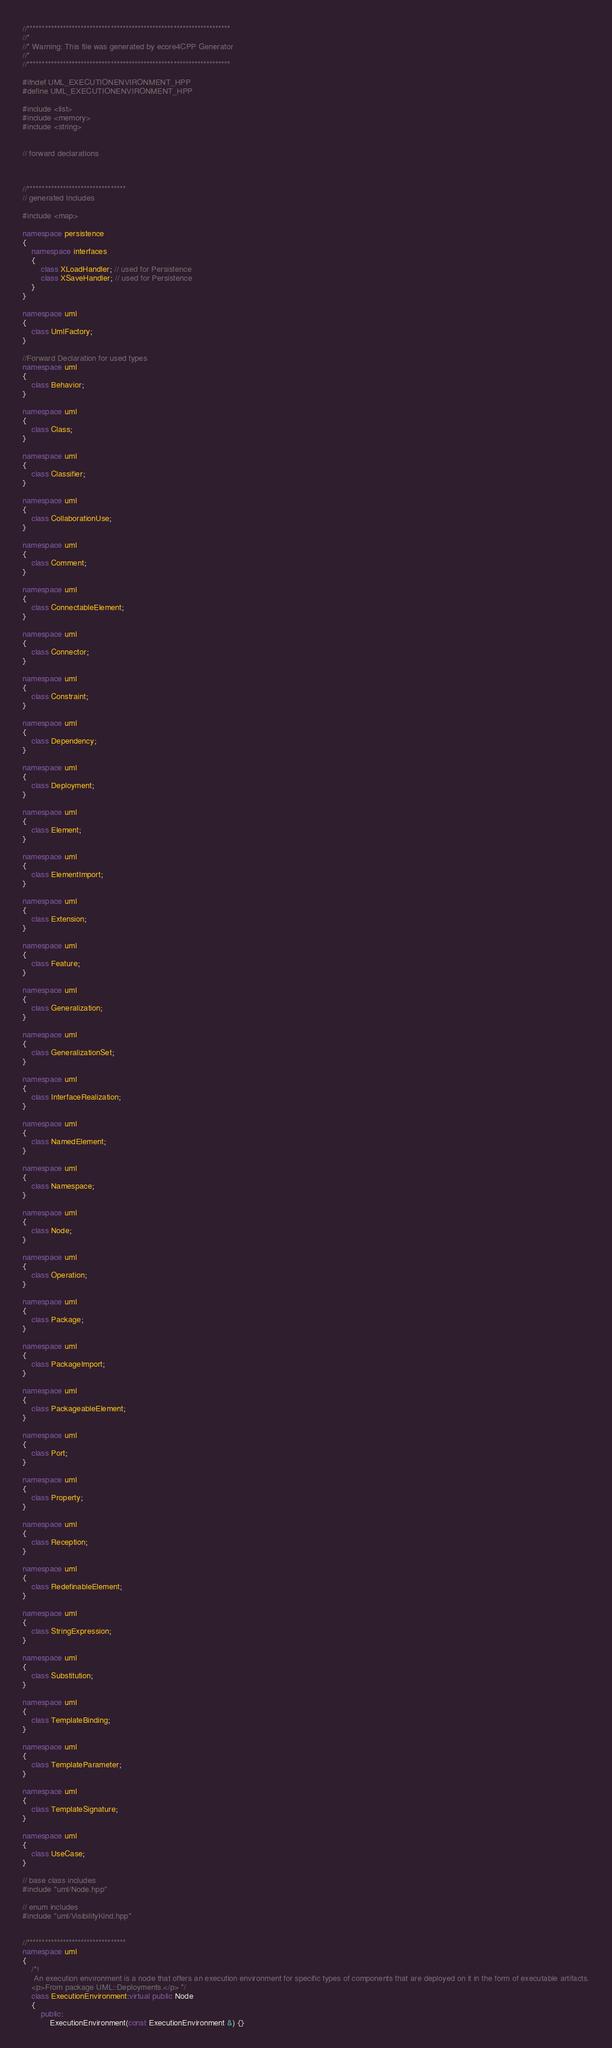Convert code to text. <code><loc_0><loc_0><loc_500><loc_500><_C++_>//********************************************************************
//*    
//* Warning: This file was generated by ecore4CPP Generator
//*
//********************************************************************

#ifndef UML_EXECUTIONENVIRONMENT_HPP
#define UML_EXECUTIONENVIRONMENT_HPP

#include <list>
#include <memory>
#include <string>


// forward declarations



//*********************************
// generated Includes

#include <map>

namespace persistence
{
	namespace interfaces
	{
		class XLoadHandler; // used for Persistence
		class XSaveHandler; // used for Persistence
	}
}

namespace uml
{
	class UmlFactory;
}

//Forward Declaration for used types
namespace uml 
{
	class Behavior;
}

namespace uml 
{
	class Class;
}

namespace uml 
{
	class Classifier;
}

namespace uml 
{
	class CollaborationUse;
}

namespace uml 
{
	class Comment;
}

namespace uml 
{
	class ConnectableElement;
}

namespace uml 
{
	class Connector;
}

namespace uml 
{
	class Constraint;
}

namespace uml 
{
	class Dependency;
}

namespace uml 
{
	class Deployment;
}

namespace uml 
{
	class Element;
}

namespace uml 
{
	class ElementImport;
}

namespace uml 
{
	class Extension;
}

namespace uml 
{
	class Feature;
}

namespace uml 
{
	class Generalization;
}

namespace uml 
{
	class GeneralizationSet;
}

namespace uml 
{
	class InterfaceRealization;
}

namespace uml 
{
	class NamedElement;
}

namespace uml 
{
	class Namespace;
}

namespace uml 
{
	class Node;
}

namespace uml 
{
	class Operation;
}

namespace uml 
{
	class Package;
}

namespace uml 
{
	class PackageImport;
}

namespace uml 
{
	class PackageableElement;
}

namespace uml 
{
	class Port;
}

namespace uml 
{
	class Property;
}

namespace uml 
{
	class Reception;
}

namespace uml 
{
	class RedefinableElement;
}

namespace uml 
{
	class StringExpression;
}

namespace uml 
{
	class Substitution;
}

namespace uml 
{
	class TemplateBinding;
}

namespace uml 
{
	class TemplateParameter;
}

namespace uml 
{
	class TemplateSignature;
}

namespace uml 
{
	class UseCase;
}

// base class includes
#include "uml/Node.hpp"

// enum includes
#include "uml/VisibilityKind.hpp"


//*********************************
namespace uml 
{
	/*!
	 An execution environment is a node that offers an execution environment for specific types of components that are deployed on it in the form of executable artifacts.
	<p>From package UML::Deployments.</p> */
	class ExecutionEnvironment:virtual public Node
	{
		public:
 			ExecutionEnvironment(const ExecutionEnvironment &) {}</code> 